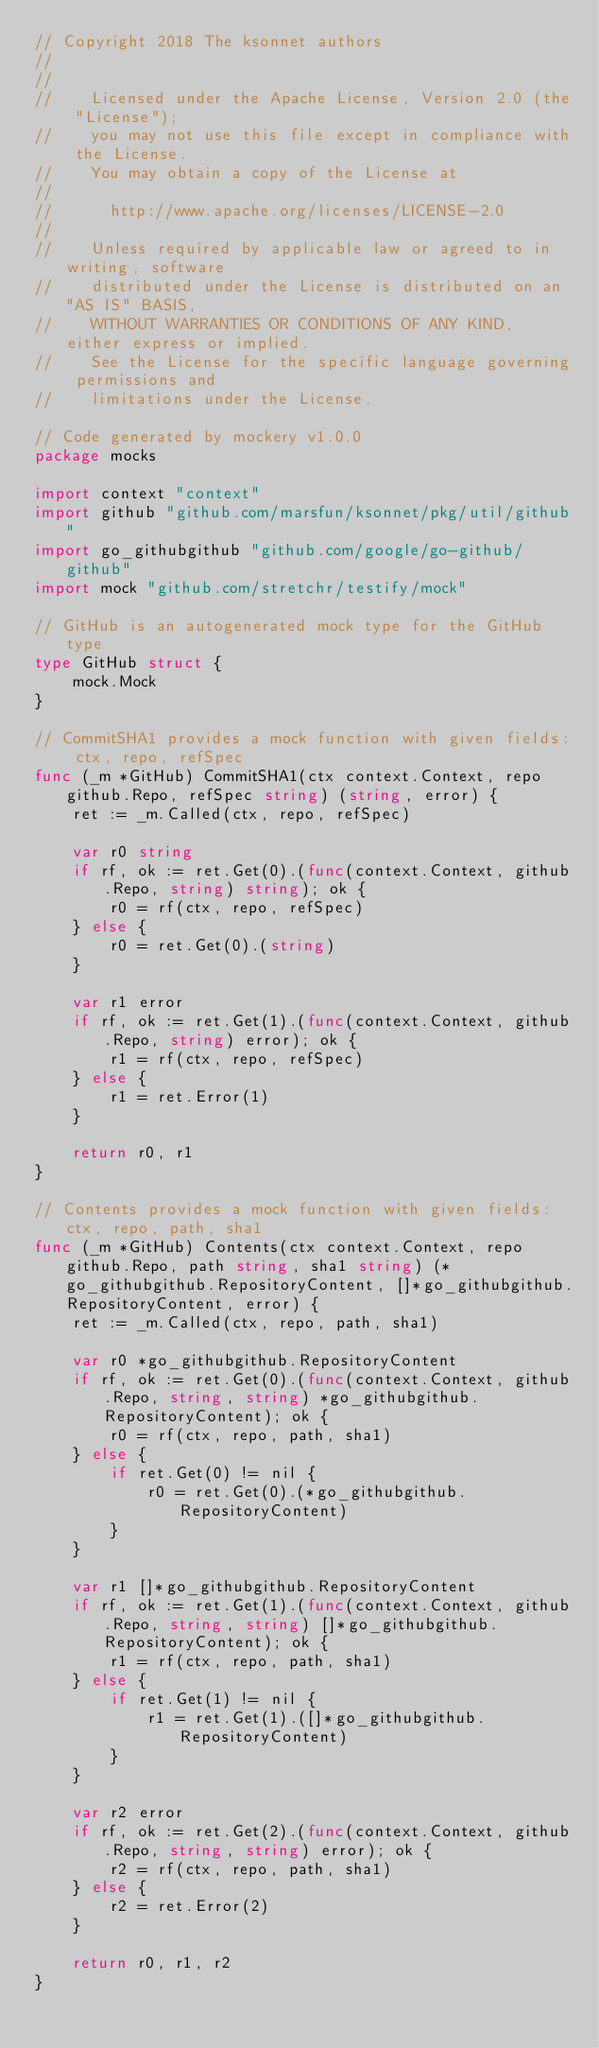Convert code to text. <code><loc_0><loc_0><loc_500><loc_500><_Go_>// Copyright 2018 The ksonnet authors
//
//
//    Licensed under the Apache License, Version 2.0 (the "License");
//    you may not use this file except in compliance with the License.
//    You may obtain a copy of the License at
//
//      http://www.apache.org/licenses/LICENSE-2.0
//
//    Unless required by applicable law or agreed to in writing, software
//    distributed under the License is distributed on an "AS IS" BASIS,
//    WITHOUT WARRANTIES OR CONDITIONS OF ANY KIND, either express or implied.
//    See the License for the specific language governing permissions and
//    limitations under the License.

// Code generated by mockery v1.0.0
package mocks

import context "context"
import github "github.com/marsfun/ksonnet/pkg/util/github"
import go_githubgithub "github.com/google/go-github/github"
import mock "github.com/stretchr/testify/mock"

// GitHub is an autogenerated mock type for the GitHub type
type GitHub struct {
	mock.Mock
}

// CommitSHA1 provides a mock function with given fields: ctx, repo, refSpec
func (_m *GitHub) CommitSHA1(ctx context.Context, repo github.Repo, refSpec string) (string, error) {
	ret := _m.Called(ctx, repo, refSpec)

	var r0 string
	if rf, ok := ret.Get(0).(func(context.Context, github.Repo, string) string); ok {
		r0 = rf(ctx, repo, refSpec)
	} else {
		r0 = ret.Get(0).(string)
	}

	var r1 error
	if rf, ok := ret.Get(1).(func(context.Context, github.Repo, string) error); ok {
		r1 = rf(ctx, repo, refSpec)
	} else {
		r1 = ret.Error(1)
	}

	return r0, r1
}

// Contents provides a mock function with given fields: ctx, repo, path, sha1
func (_m *GitHub) Contents(ctx context.Context, repo github.Repo, path string, sha1 string) (*go_githubgithub.RepositoryContent, []*go_githubgithub.RepositoryContent, error) {
	ret := _m.Called(ctx, repo, path, sha1)

	var r0 *go_githubgithub.RepositoryContent
	if rf, ok := ret.Get(0).(func(context.Context, github.Repo, string, string) *go_githubgithub.RepositoryContent); ok {
		r0 = rf(ctx, repo, path, sha1)
	} else {
		if ret.Get(0) != nil {
			r0 = ret.Get(0).(*go_githubgithub.RepositoryContent)
		}
	}

	var r1 []*go_githubgithub.RepositoryContent
	if rf, ok := ret.Get(1).(func(context.Context, github.Repo, string, string) []*go_githubgithub.RepositoryContent); ok {
		r1 = rf(ctx, repo, path, sha1)
	} else {
		if ret.Get(1) != nil {
			r1 = ret.Get(1).([]*go_githubgithub.RepositoryContent)
		}
	}

	var r2 error
	if rf, ok := ret.Get(2).(func(context.Context, github.Repo, string, string) error); ok {
		r2 = rf(ctx, repo, path, sha1)
	} else {
		r2 = ret.Error(2)
	}

	return r0, r1, r2
}
</code> 